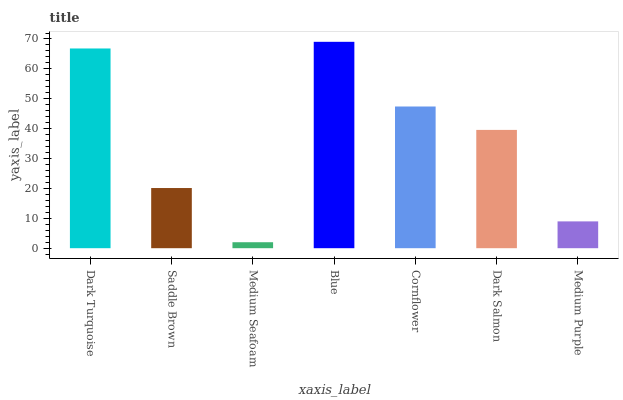Is Medium Seafoam the minimum?
Answer yes or no. Yes. Is Blue the maximum?
Answer yes or no. Yes. Is Saddle Brown the minimum?
Answer yes or no. No. Is Saddle Brown the maximum?
Answer yes or no. No. Is Dark Turquoise greater than Saddle Brown?
Answer yes or no. Yes. Is Saddle Brown less than Dark Turquoise?
Answer yes or no. Yes. Is Saddle Brown greater than Dark Turquoise?
Answer yes or no. No. Is Dark Turquoise less than Saddle Brown?
Answer yes or no. No. Is Dark Salmon the high median?
Answer yes or no. Yes. Is Dark Salmon the low median?
Answer yes or no. Yes. Is Medium Purple the high median?
Answer yes or no. No. Is Blue the low median?
Answer yes or no. No. 